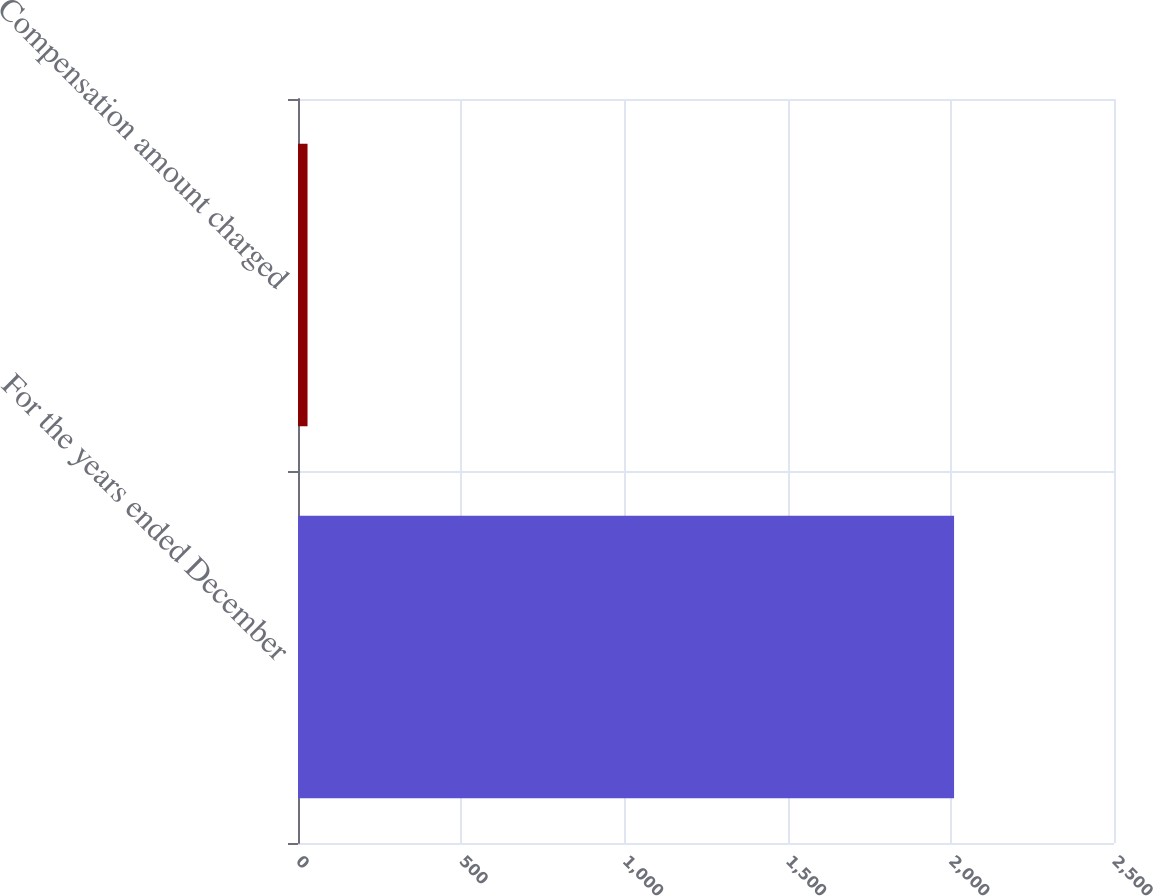Convert chart. <chart><loc_0><loc_0><loc_500><loc_500><bar_chart><fcel>For the years ended December<fcel>Compensation amount charged<nl><fcel>2010<fcel>29.2<nl></chart> 